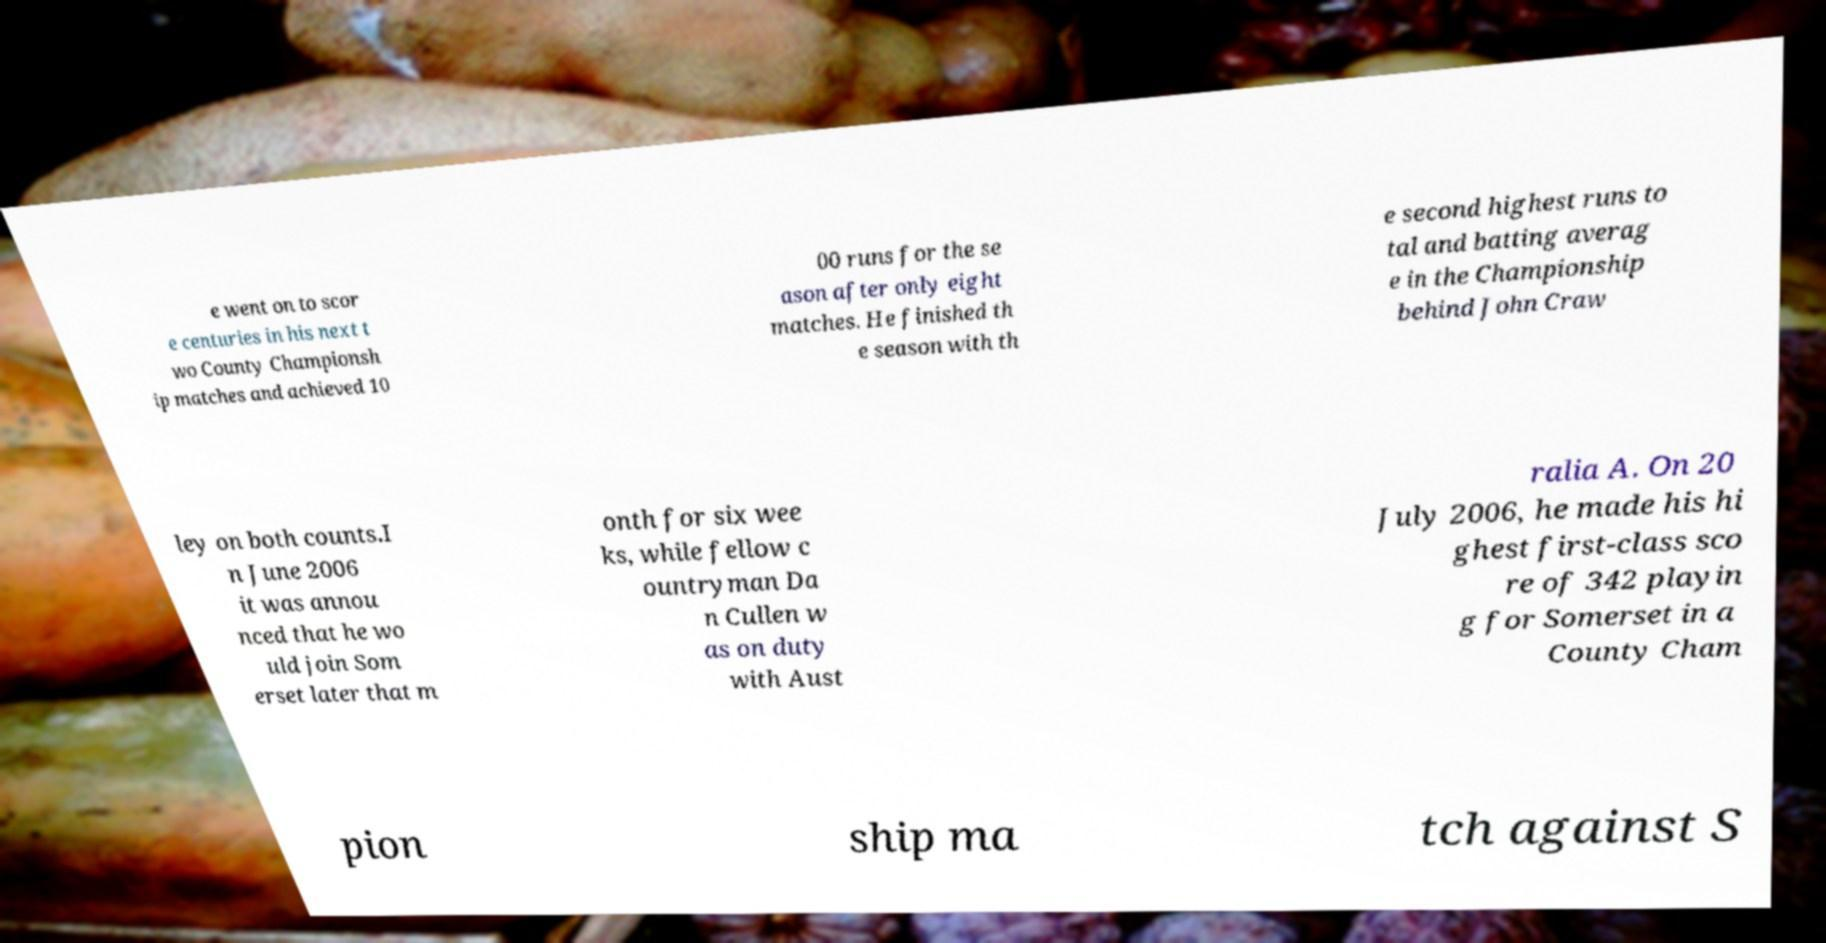Can you read and provide the text displayed in the image?This photo seems to have some interesting text. Can you extract and type it out for me? e went on to scor e centuries in his next t wo County Championsh ip matches and achieved 10 00 runs for the se ason after only eight matches. He finished th e season with th e second highest runs to tal and batting averag e in the Championship behind John Craw ley on both counts.I n June 2006 it was annou nced that he wo uld join Som erset later that m onth for six wee ks, while fellow c ountryman Da n Cullen w as on duty with Aust ralia A. On 20 July 2006, he made his hi ghest first-class sco re of 342 playin g for Somerset in a County Cham pion ship ma tch against S 